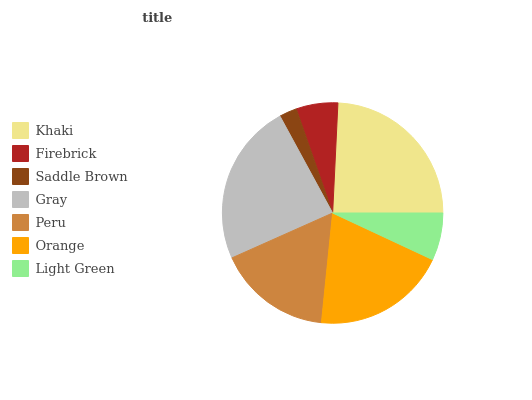Is Saddle Brown the minimum?
Answer yes or no. Yes. Is Khaki the maximum?
Answer yes or no. Yes. Is Firebrick the minimum?
Answer yes or no. No. Is Firebrick the maximum?
Answer yes or no. No. Is Khaki greater than Firebrick?
Answer yes or no. Yes. Is Firebrick less than Khaki?
Answer yes or no. Yes. Is Firebrick greater than Khaki?
Answer yes or no. No. Is Khaki less than Firebrick?
Answer yes or no. No. Is Peru the high median?
Answer yes or no. Yes. Is Peru the low median?
Answer yes or no. Yes. Is Light Green the high median?
Answer yes or no. No. Is Orange the low median?
Answer yes or no. No. 